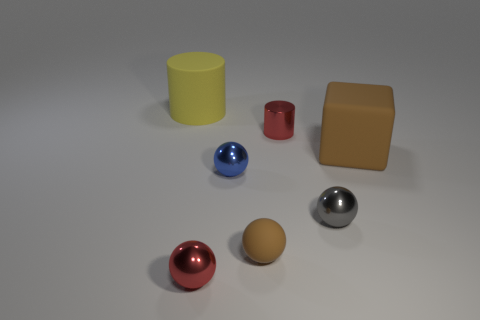What shape is the object that is the same color as the tiny metal cylinder?
Your answer should be compact. Sphere. There is a tiny object that is made of the same material as the large cube; what is its shape?
Keep it short and to the point. Sphere. Is there anything else of the same color as the small matte sphere?
Provide a short and direct response. Yes. There is a small rubber thing; is it the same color as the cylinder on the right side of the big cylinder?
Give a very brief answer. No. Are there fewer small red things on the right side of the small rubber object than tiny brown shiny blocks?
Ensure brevity in your answer.  No. There is a red thing to the left of the tiny red shiny cylinder; what is its material?
Your answer should be very brief. Metal. What number of other things are there of the same size as the gray shiny object?
Offer a very short reply. 4. Is the size of the gray ball the same as the matte thing that is in front of the brown block?
Your answer should be compact. Yes. What is the shape of the big thing that is on the right side of the large thing to the left of the big matte object right of the matte cylinder?
Ensure brevity in your answer.  Cube. Is the number of brown rubber things less than the number of small yellow matte spheres?
Provide a short and direct response. No. 